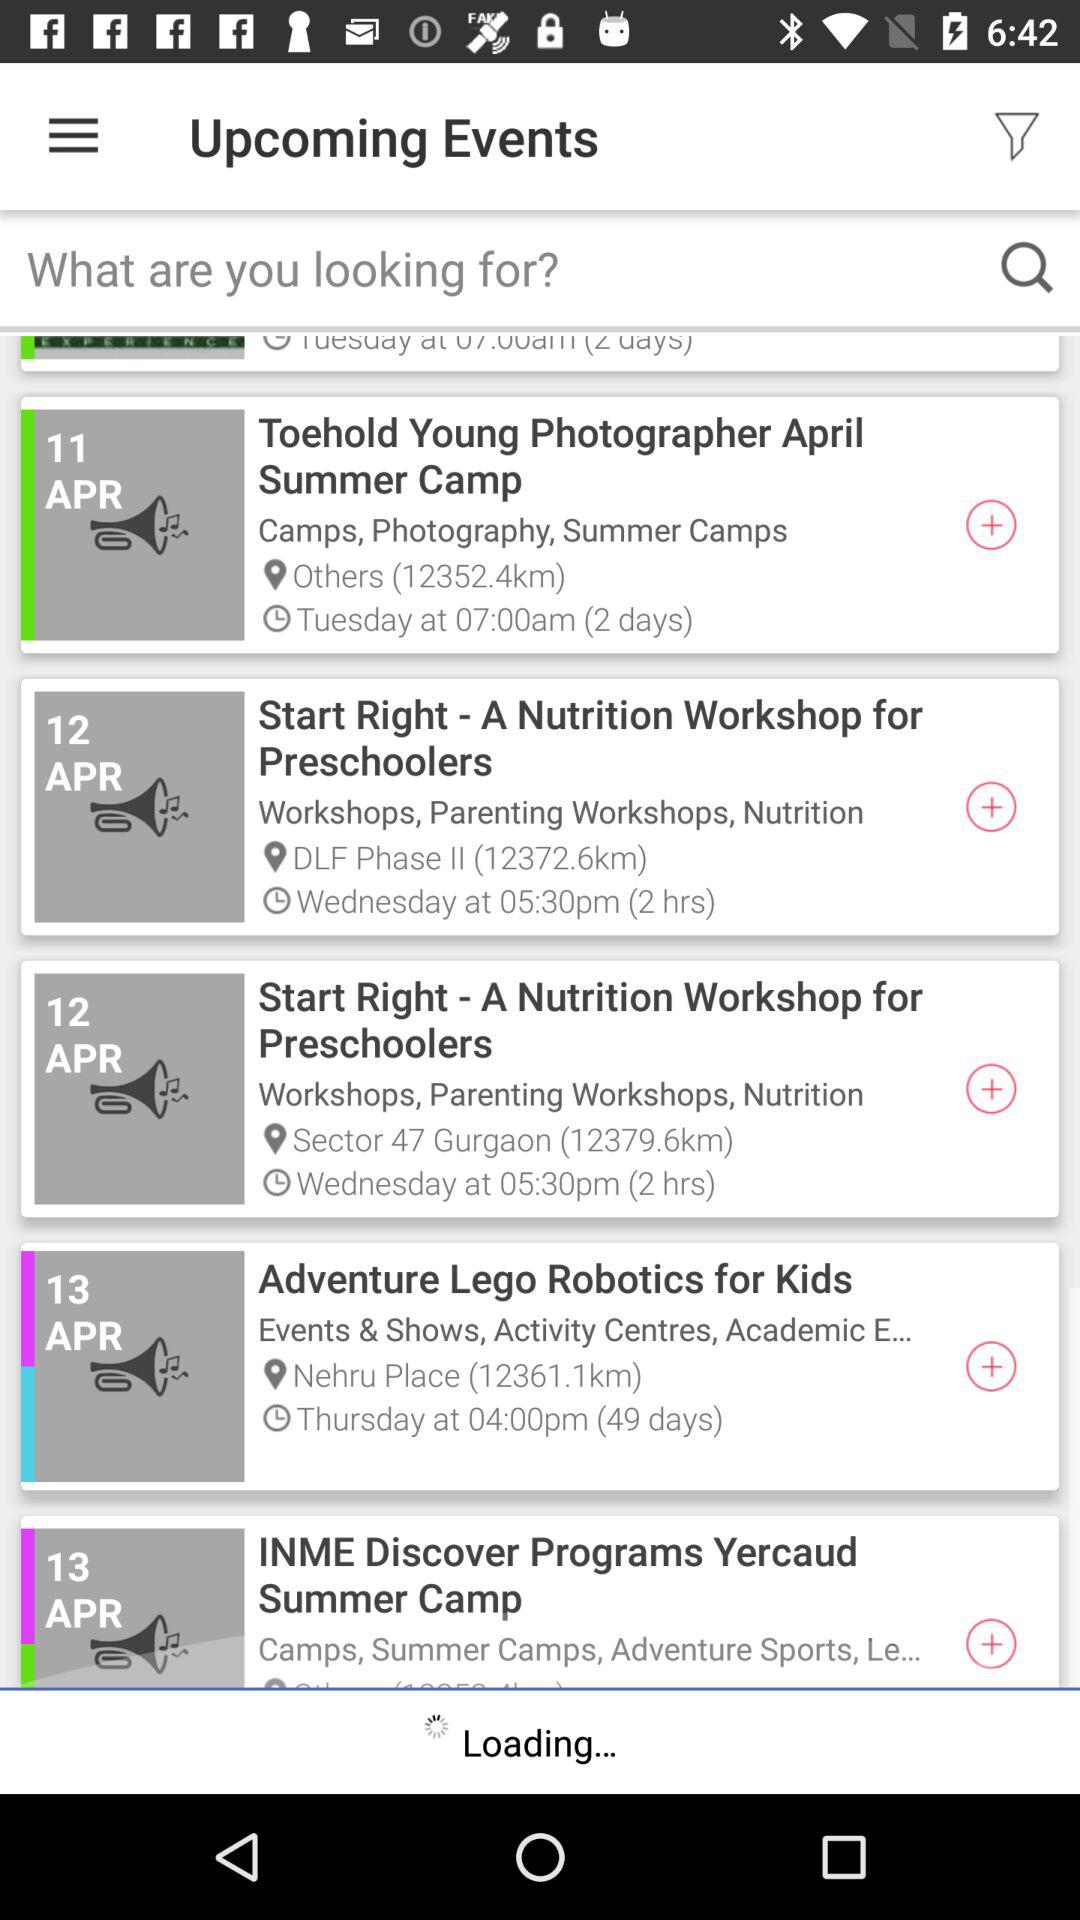What is the event time of "Start Right - A Nutrition Workshop for Preschoolers"? The event time is 05:30 PM. 